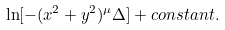<formula> <loc_0><loc_0><loc_500><loc_500>\ln [ - ( x ^ { 2 } + y ^ { 2 } ) ^ { \mu } \Delta ] + c o n s t a n t .</formula> 